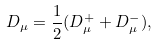<formula> <loc_0><loc_0><loc_500><loc_500>D _ { \mu } = \frac { 1 } { 2 } ( D ^ { + } _ { \mu } + D ^ { - } _ { \mu } ) ,</formula> 